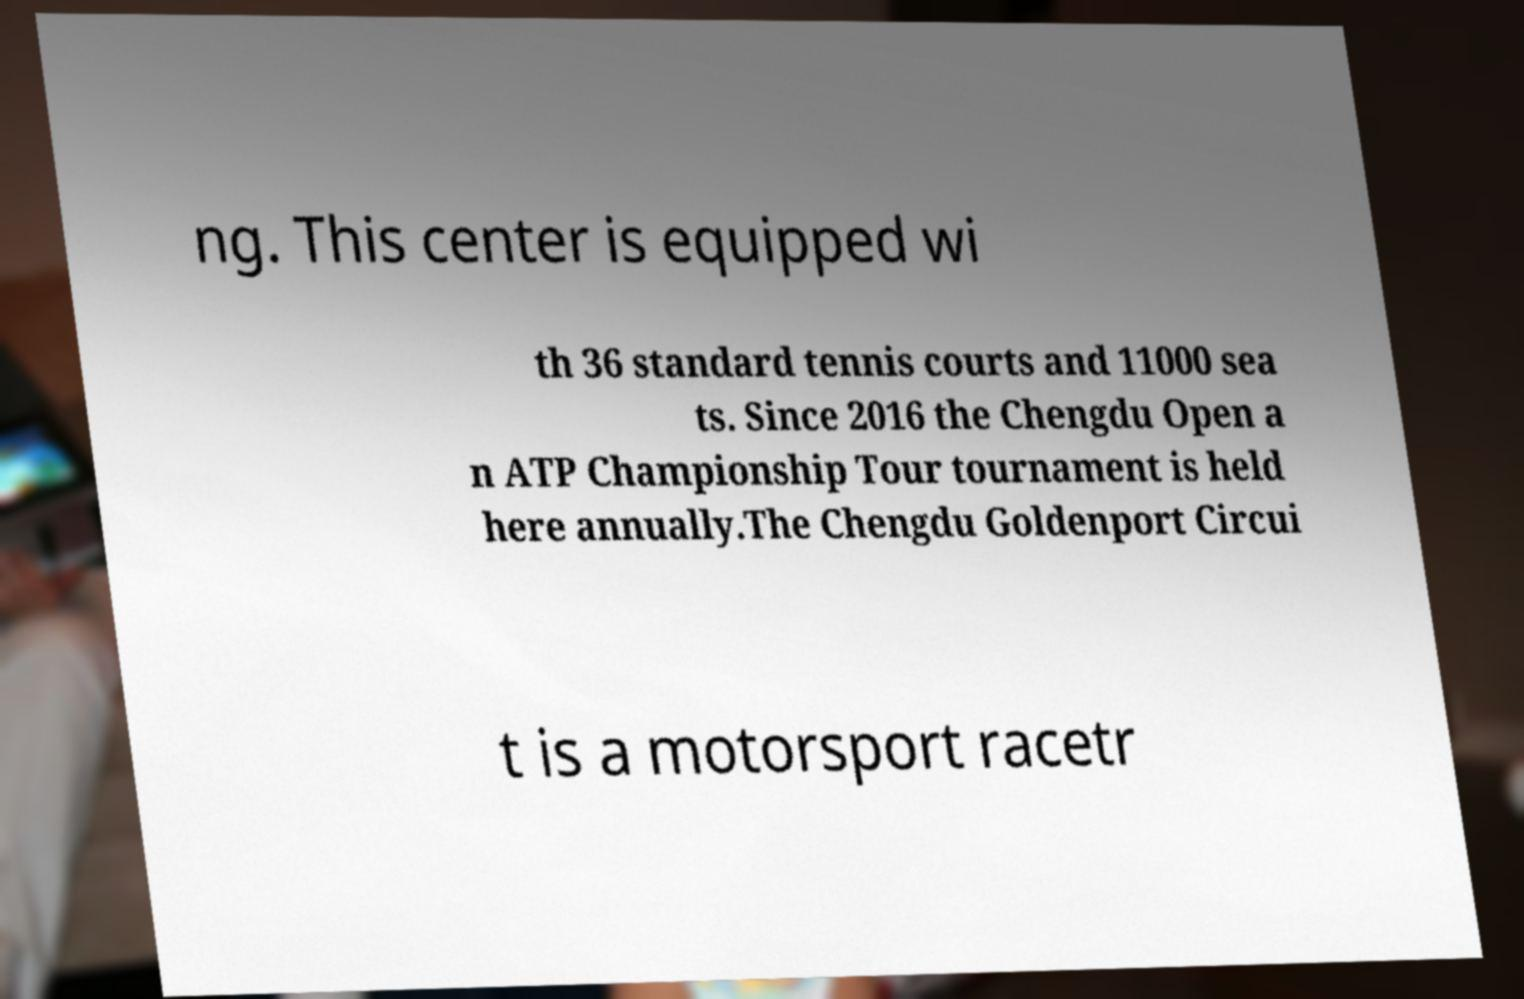Please identify and transcribe the text found in this image. ng. This center is equipped wi th 36 standard tennis courts and 11000 sea ts. Since 2016 the Chengdu Open a n ATP Championship Tour tournament is held here annually.The Chengdu Goldenport Circui t is a motorsport racetr 